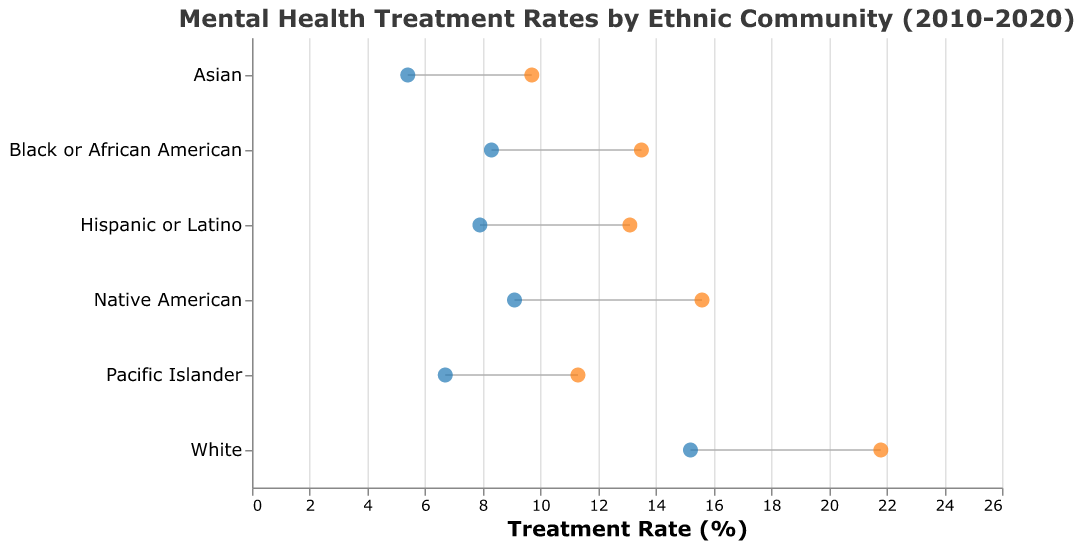What is the title of the figure? The title of the figure is displayed at the top and summarizes the content of the chart. The title reads "Mental Health Treatment Rates by Ethnic Community (2010-2020)"
Answer: Mental Health Treatment Rates by Ethnic Community (2010-2020) Which ethnic community had the highest treatment rate in 2010? To find the highest treatment rate from the 2010 data, scan through the circles on the left representing 2010 rates for each ethnic community. The highest circle on the x-axis will correspond to the community with the highest treatment rate.
Answer: White How much did the treatment rate increase for the Hispanic or Latino community between 2010 and 2020? Locate the Hispanic or Latino row, then identify the treatment rates for 2010 and 2020. Calculate the difference: 13.1 (2020) - 7.9 (2010) = 5.2
Answer: 5.2 What are the treatment rates for the Pacific Islander community in 2020? Identify the row labeled "Pacific Islander" and look at the corresponding treatment rate for 2020, indicated by the orange circle.
Answer: 11.3 Which ethnic community showed the smallest increase in treatment rates from 2010 to 2020? Calculate the treatment rate increase for each community by subtracting 2010 rates from 2020 rates for each community. The community with the smallest difference will be the answer.
Answer: Asian How many ethnic communities had a treatment rate lower than 10% in 2010? Count the number of circles on the left (2010 data) positioned on the x-axis at values lower than 10%.
Answer: 3 Which ethnic community had the lowest treatment rate in 2020? Examine the right-hand circles (2020 data) for each ethnic community and identify the lowest circle on the x-axis.
Answer: Asian By how much did the treatment rate for the Native American community increase from 2010 to 2020? Find the treatment rates for Native Americans in 2010 and 2020. Then, calculate the increase: 15.6 (2020) - 9.1 (2010) = 6.5
Answer: 6.5 Which ethnic community showed the largest absolute increase in treatment rates? Calculate the absolute increase in treatment rates for each community (2020 rate - 2010 rate) and identify the community with the largest increase.
Answer: White Do any ethnic communities have the same treatment rate in both 2010 and 2020? Compare the treatment rates for each ethnic community for both years. If any rates match, the answer is yes; otherwise, no.
Answer: No 